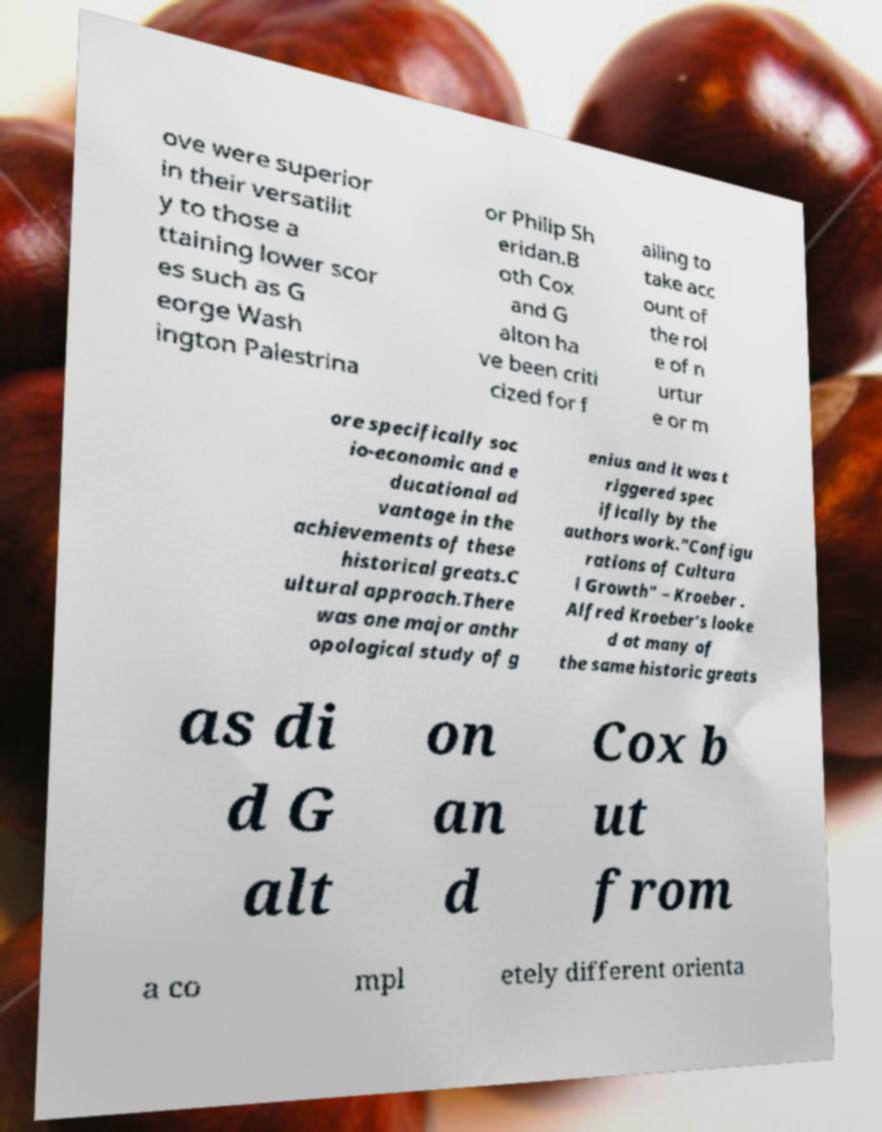What messages or text are displayed in this image? I need them in a readable, typed format. ove were superior in their versatilit y to those a ttaining lower scor es such as G eorge Wash ington Palestrina or Philip Sh eridan.B oth Cox and G alton ha ve been criti cized for f ailing to take acc ount of the rol e of n urtur e or m ore specifically soc io-economic and e ducational ad vantage in the achievements of these historical greats.C ultural approach.There was one major anthr opological study of g enius and it was t riggered spec ifically by the authors work."Configu rations of Cultura l Growth" – Kroeber . Alfred Kroeber’s looke d at many of the same historic greats as di d G alt on an d Cox b ut from a co mpl etely different orienta 